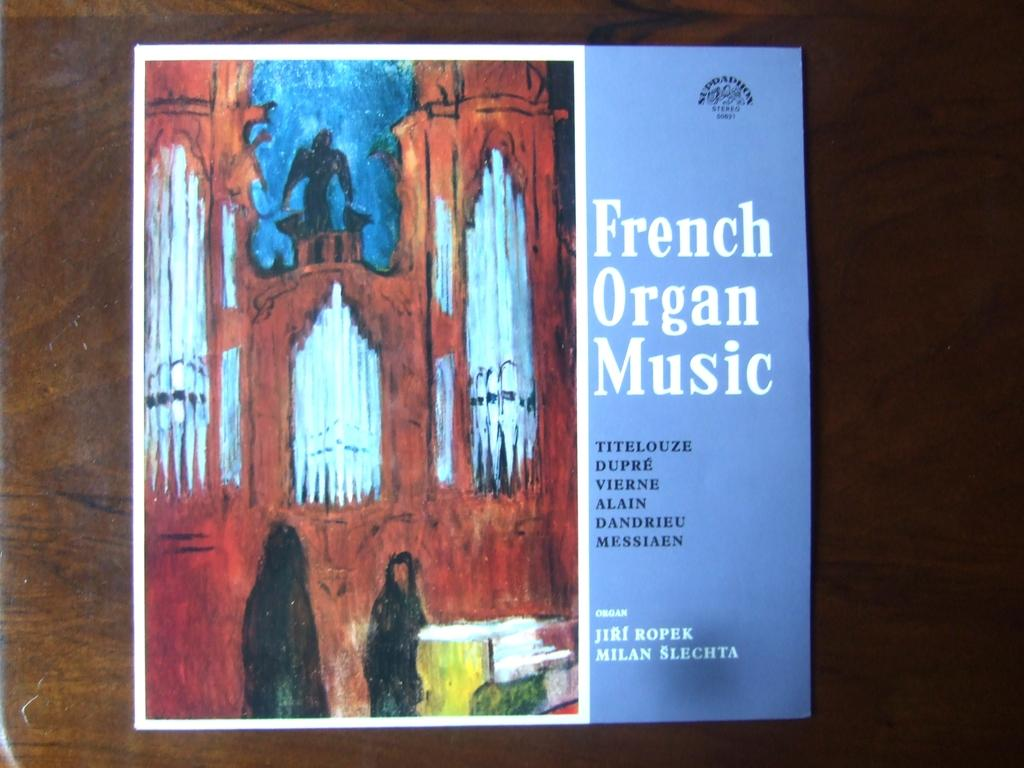<image>
Share a concise interpretation of the image provided. An album of French Organ Music has a creepy cover. 